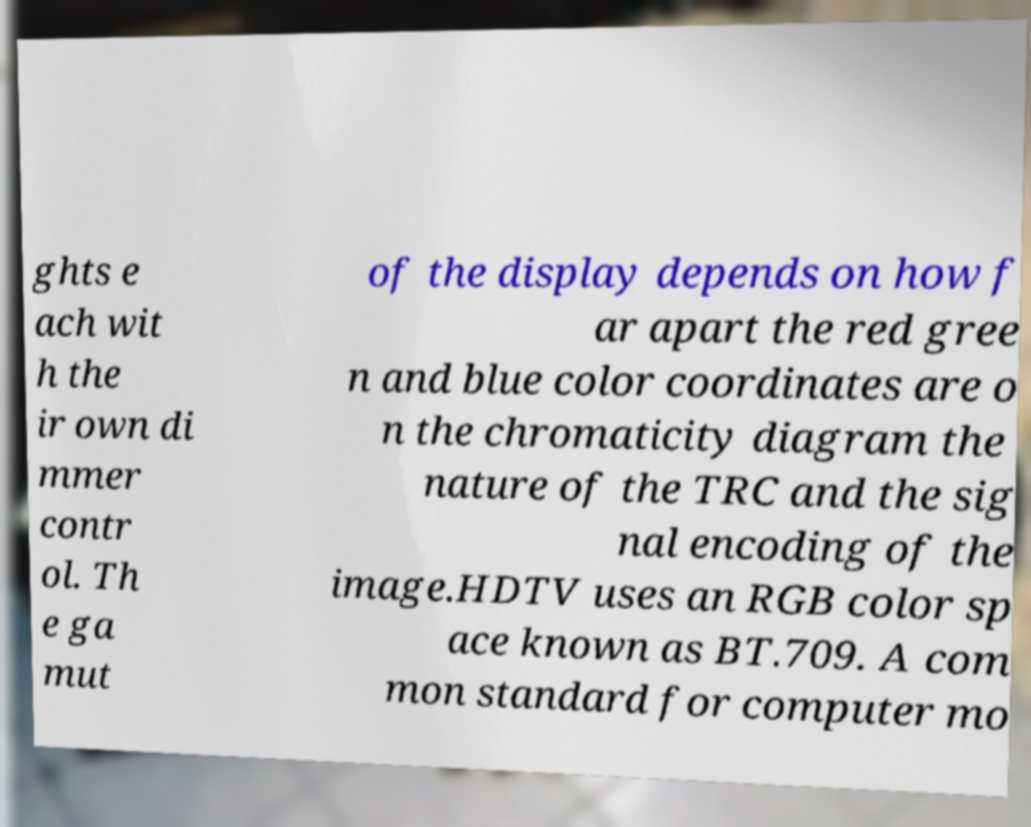Can you read and provide the text displayed in the image?This photo seems to have some interesting text. Can you extract and type it out for me? ghts e ach wit h the ir own di mmer contr ol. Th e ga mut of the display depends on how f ar apart the red gree n and blue color coordinates are o n the chromaticity diagram the nature of the TRC and the sig nal encoding of the image.HDTV uses an RGB color sp ace known as BT.709. A com mon standard for computer mo 